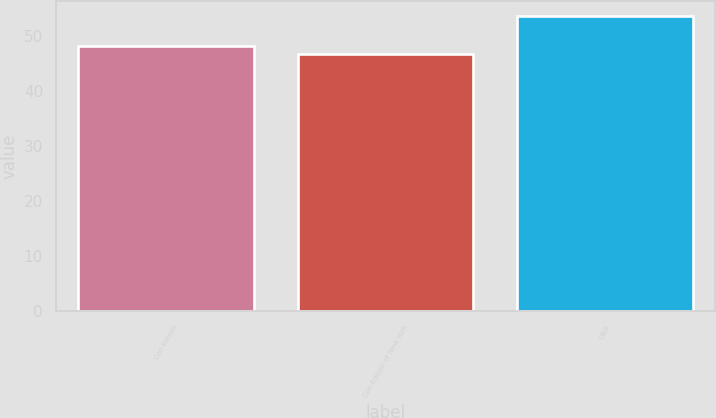Convert chart to OTSL. <chart><loc_0><loc_0><loc_500><loc_500><bar_chart><fcel>Con Edison<fcel>Con Edison of New York<fcel>O&R<nl><fcel>48.1<fcel>46.6<fcel>53.6<nl></chart> 